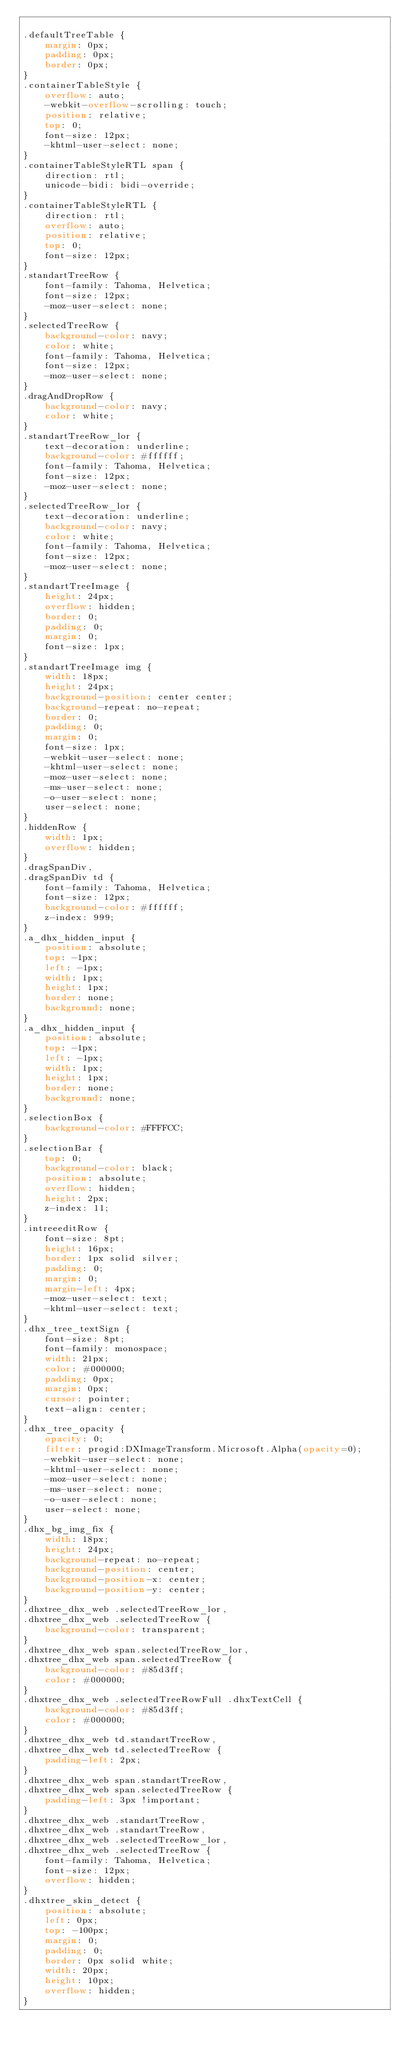Convert code to text. <code><loc_0><loc_0><loc_500><loc_500><_CSS_>
.defaultTreeTable {
	margin: 0px;
	padding: 0px;
	border: 0px;
}
.containerTableStyle {
	overflow: auto;
	-webkit-overflow-scrolling: touch;
	position: relative;
	top: 0;
	font-size: 12px;
	-khtml-user-select: none;
}
.containerTableStyleRTL span {
	direction: rtl;
	unicode-bidi: bidi-override;
}
.containerTableStyleRTL {
	direction: rtl;
	overflow: auto;
	position: relative;
	top: 0;
	font-size: 12px;
}
.standartTreeRow {
	font-family: Tahoma, Helvetica;
	font-size: 12px;
	-moz-user-select: none;
}
.selectedTreeRow {
	background-color: navy;
	color: white;
	font-family: Tahoma, Helvetica;
	font-size: 12px;
	-moz-user-select: none;
}
.dragAndDropRow {
	background-color: navy;
	color: white;
}
.standartTreeRow_lor {
	text-decoration: underline;
	background-color: #ffffff;
	font-family: Tahoma, Helvetica;
	font-size: 12px;
	-moz-user-select: none;
}
.selectedTreeRow_lor {
	text-decoration: underline;
	background-color: navy;
	color: white;
	font-family: Tahoma, Helvetica;
	font-size: 12px;
	-moz-user-select: none;
}
.standartTreeImage {
	height: 24px;
	overflow: hidden;
	border: 0;
	padding: 0;
	margin: 0;
	font-size: 1px;
}
.standartTreeImage img {
	width: 18px;
	height: 24px;
	background-position: center center;
	background-repeat: no-repeat;
	border: 0;
	padding: 0;
	margin: 0;
	font-size: 1px;
	-webkit-user-select: none;
	-khtml-user-select: none;
	-moz-user-select: none;
	-ms-user-select: none;
	-o-user-select: none;
	user-select: none;
}
.hiddenRow {
	width: 1px;
	overflow: hidden;
}
.dragSpanDiv,
.dragSpanDiv td {
	font-family: Tahoma, Helvetica;
	font-size: 12px;
	background-color: #ffffff;
	z-index: 999;
}
.a_dhx_hidden_input {
	position: absolute;
	top: -1px;
	left: -1px;
	width: 1px;
	height: 1px;
	border: none;
	background: none;
}
.a_dhx_hidden_input {
	position: absolute;
	top: -1px;
	left: -1px;
	width: 1px;
	height: 1px;
	border: none;
	background: none;
}
.selectionBox {
	background-color: #FFFFCC;
}
.selectionBar {
	top: 0;
	background-color: black;
	position: absolute;
	overflow: hidden;
	height: 2px;
	z-index: 11;
}
.intreeeditRow {
	font-size: 8pt;
	height: 16px;
	border: 1px solid silver;
	padding: 0;
	margin: 0;
	margin-left: 4px;
	-moz-user-select: text;
	-khtml-user-select: text;
}
.dhx_tree_textSign {
	font-size: 8pt;
	font-family: monospace;
	width: 21px;
	color: #000000;
	padding: 0px;
	margin: 0px;
	cursor: pointer;
	text-align: center;
}
.dhx_tree_opacity {
	opacity: 0;
	filter: progid:DXImageTransform.Microsoft.Alpha(opacity=0);
	-webkit-user-select: none;
	-khtml-user-select: none;
	-moz-user-select: none;
	-ms-user-select: none;
	-o-user-select: none;
	user-select: none;
}
.dhx_bg_img_fix {
	width: 18px;
	height: 24px;
	background-repeat: no-repeat;
	background-position: center;
	background-position-x: center;
	background-position-y: center;
}
.dhxtree_dhx_web .selectedTreeRow_lor,
.dhxtree_dhx_web .selectedTreeRow {
	background-color: transparent;
}
.dhxtree_dhx_web span.selectedTreeRow_lor,
.dhxtree_dhx_web span.selectedTreeRow {
	background-color: #85d3ff;
	color: #000000;
}
.dhxtree_dhx_web .selectedTreeRowFull .dhxTextCell {
	background-color: #85d3ff;
	color: #000000;
}
.dhxtree_dhx_web td.standartTreeRow,
.dhxtree_dhx_web td.selectedTreeRow {
	padding-left: 2px;
}
.dhxtree_dhx_web span.standartTreeRow,
.dhxtree_dhx_web span.selectedTreeRow {
	padding-left: 3px !important;
}
.dhxtree_dhx_web .standartTreeRow,
.dhxtree_dhx_web .standartTreeRow,
.dhxtree_dhx_web .selectedTreeRow_lor,
.dhxtree_dhx_web .selectedTreeRow {
	font-family: Tahoma, Helvetica;
	font-size: 12px;
	overflow: hidden;
}
.dhxtree_skin_detect {
	position: absolute;
	left: 0px;
	top: -100px;
	margin: 0;
	padding: 0;
	border: 0px solid white;
	width: 20px;
	height: 10px;
	overflow: hidden;
}
</code> 